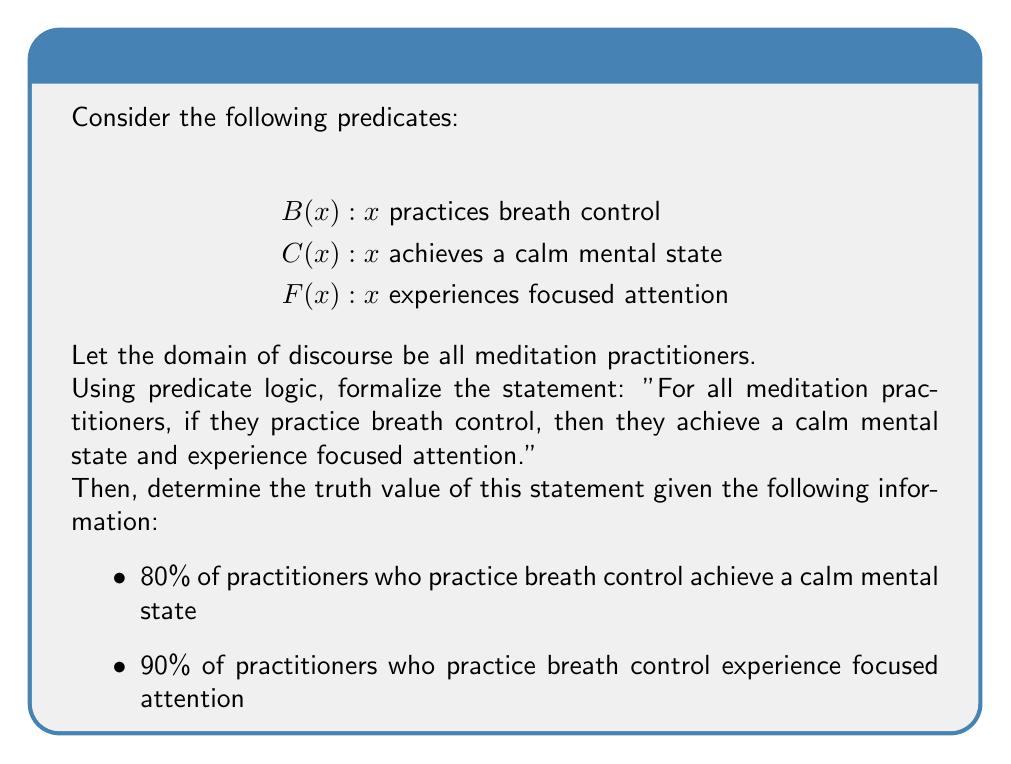Could you help me with this problem? Let's approach this step-by-step:

1) First, we need to formalize the given statement using predicate logic:

   $$\forall x (B(x) \rightarrow (C(x) \land F(x)))$$

   This reads as "For all x, if B(x) then C(x) and F(x)".

2) Now, let's analyze the truth value of this statement given the information provided:

   - 80% of practitioners who practice breath control achieve a calm mental state
   - 90% of practitioners who practice breath control experience focused attention

3) For the statement to be true, it must hold for ALL practitioners. In other words, if there's even one practitioner for whom the statement doesn't hold, the entire statement is false.

4) We can see that:
   - 20% of practitioners who practice breath control do NOT achieve a calm mental state
   - 10% of practitioners who practice breath control do NOT experience focused attention

5) This means that there exist practitioners for whom B(x) is true, but either C(x) or F(x) (or both) are false.

6) The existence of even one such practitioner makes the universal quantifier (∀) statement false.

Therefore, given the provided information, the formalized statement is false.
Answer: False 